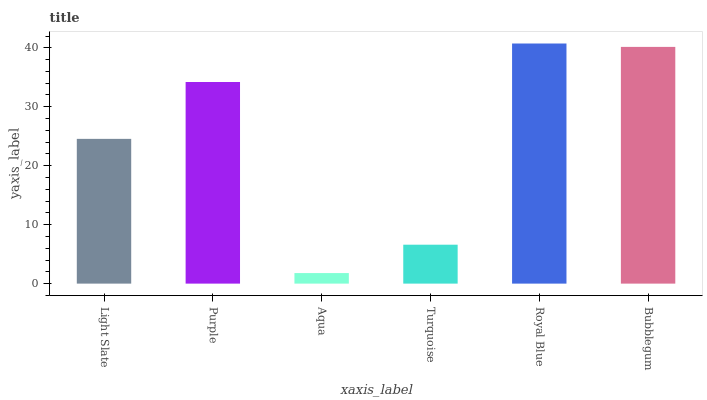Is Aqua the minimum?
Answer yes or no. Yes. Is Royal Blue the maximum?
Answer yes or no. Yes. Is Purple the minimum?
Answer yes or no. No. Is Purple the maximum?
Answer yes or no. No. Is Purple greater than Light Slate?
Answer yes or no. Yes. Is Light Slate less than Purple?
Answer yes or no. Yes. Is Light Slate greater than Purple?
Answer yes or no. No. Is Purple less than Light Slate?
Answer yes or no. No. Is Purple the high median?
Answer yes or no. Yes. Is Light Slate the low median?
Answer yes or no. Yes. Is Bubblegum the high median?
Answer yes or no. No. Is Bubblegum the low median?
Answer yes or no. No. 